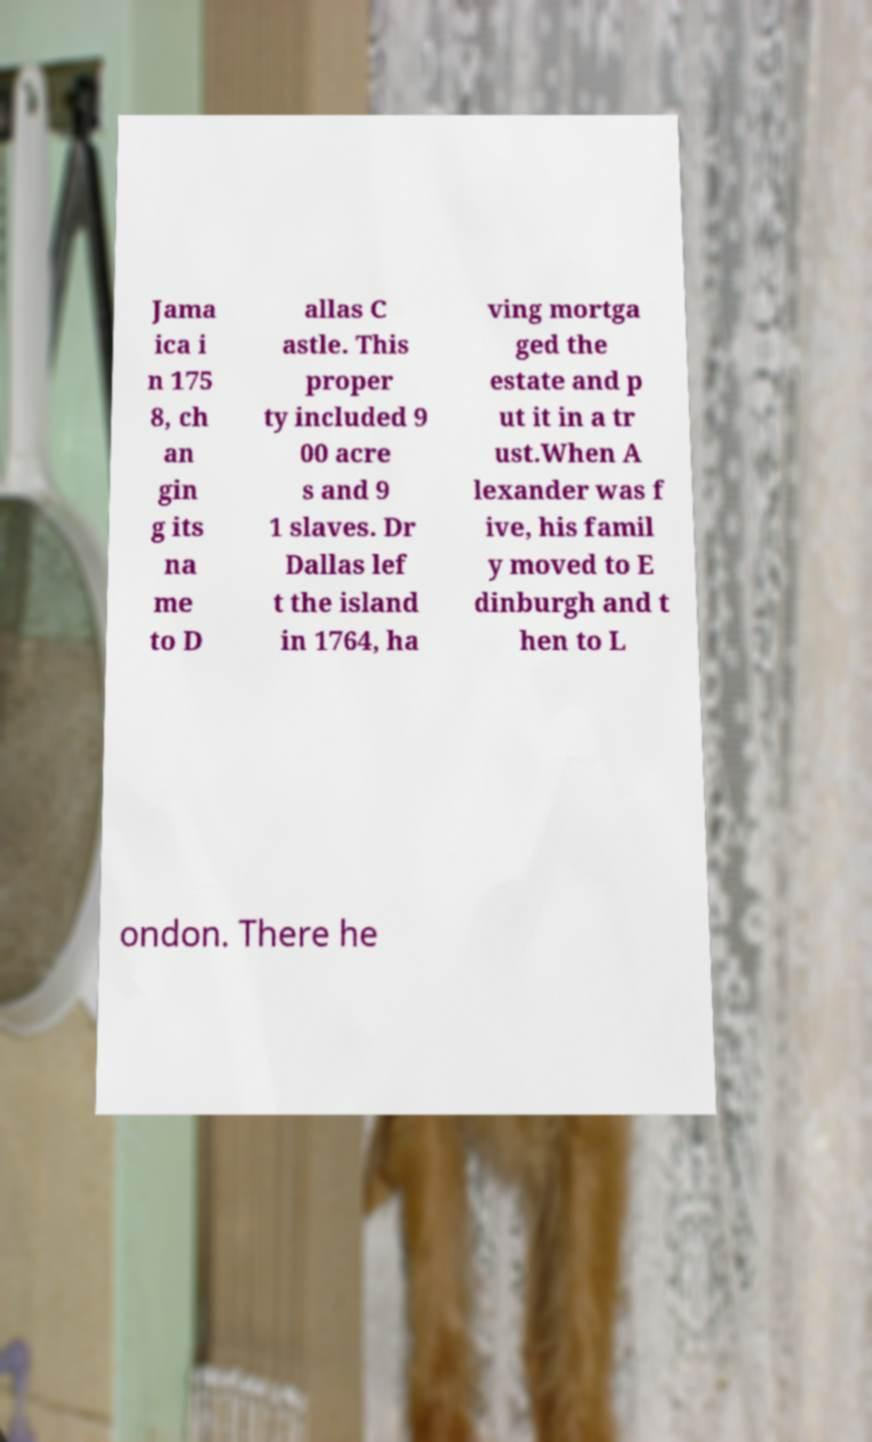Can you read and provide the text displayed in the image?This photo seems to have some interesting text. Can you extract and type it out for me? Jama ica i n 175 8, ch an gin g its na me to D allas C astle. This proper ty included 9 00 acre s and 9 1 slaves. Dr Dallas lef t the island in 1764, ha ving mortga ged the estate and p ut it in a tr ust.When A lexander was f ive, his famil y moved to E dinburgh and t hen to L ondon. There he 